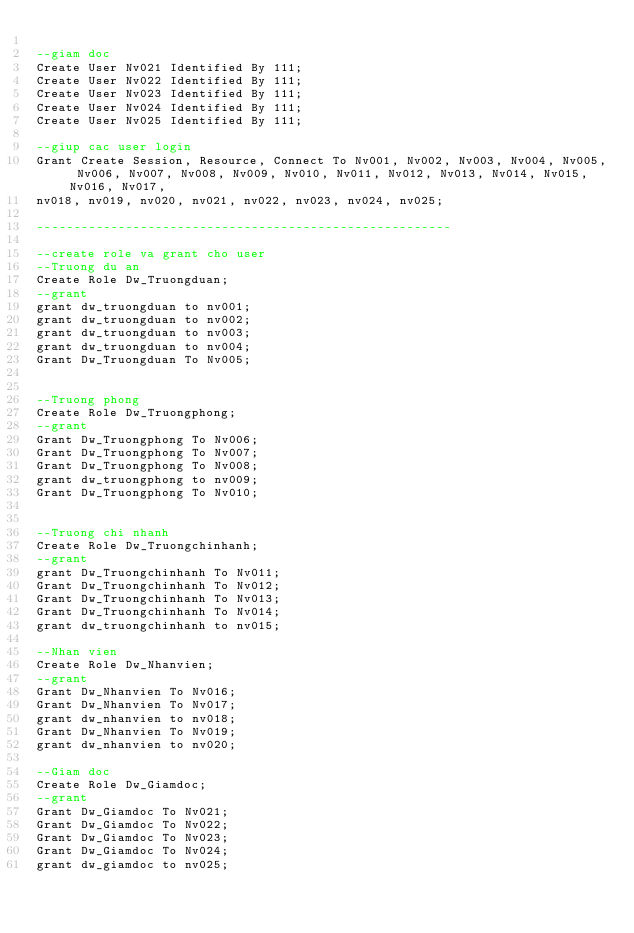<code> <loc_0><loc_0><loc_500><loc_500><_SQL_>
--giam doc
Create User Nv021 Identified By 111;
Create User Nv022 Identified By 111;
Create User Nv023 Identified By 111;
Create User Nv024 Identified By 111;
Create User Nv025 Identified By 111;

--giup cac user login
Grant Create Session, Resource, Connect To Nv001, Nv002, Nv003, Nv004, Nv005, Nv006, Nv007, Nv008, Nv009, Nv010, Nv011, Nv012, Nv013, Nv014, Nv015, Nv016, Nv017,
nv018, nv019, nv020, nv021, nv022, nv023, nv024, nv025;

--------------------------------------------------------

--create role va grant cho user
--Truong du an
Create Role Dw_Truongduan;
--grant
grant dw_truongduan to nv001;
grant dw_truongduan to nv002;
grant dw_truongduan to nv003;
grant dw_truongduan to nv004;
Grant Dw_Truongduan To Nv005;


--Truong phong
Create Role Dw_Truongphong;
--grant
Grant Dw_Truongphong To Nv006;
Grant Dw_Truongphong To Nv007;
Grant Dw_Truongphong To Nv008;
grant dw_truongphong to nv009;
Grant Dw_Truongphong To Nv010;


--Truong chi nhanh
Create Role Dw_Truongchinhanh;
--grant
grant Dw_Truongchinhanh To Nv011;
Grant Dw_Truongchinhanh To Nv012;
Grant Dw_Truongchinhanh To Nv013;
Grant Dw_Truongchinhanh To Nv014;
grant dw_truongchinhanh to nv015;

--Nhan vien
Create Role Dw_Nhanvien;
--grant
Grant Dw_Nhanvien To Nv016;
Grant Dw_Nhanvien To Nv017;
grant dw_nhanvien to nv018;
Grant Dw_Nhanvien To Nv019;
grant dw_nhanvien to nv020;

--Giam doc
Create Role Dw_Giamdoc;
--grant
Grant Dw_Giamdoc To Nv021;
Grant Dw_Giamdoc To Nv022;
Grant Dw_Giamdoc To Nv023;
Grant Dw_Giamdoc To Nv024;
grant dw_giamdoc to nv025;







</code> 